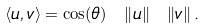Convert formula to latex. <formula><loc_0><loc_0><loc_500><loc_500>\langle u , v \rangle = \cos ( \theta ) \ \left \| u \right \| \ \left \| v \right \| .</formula> 